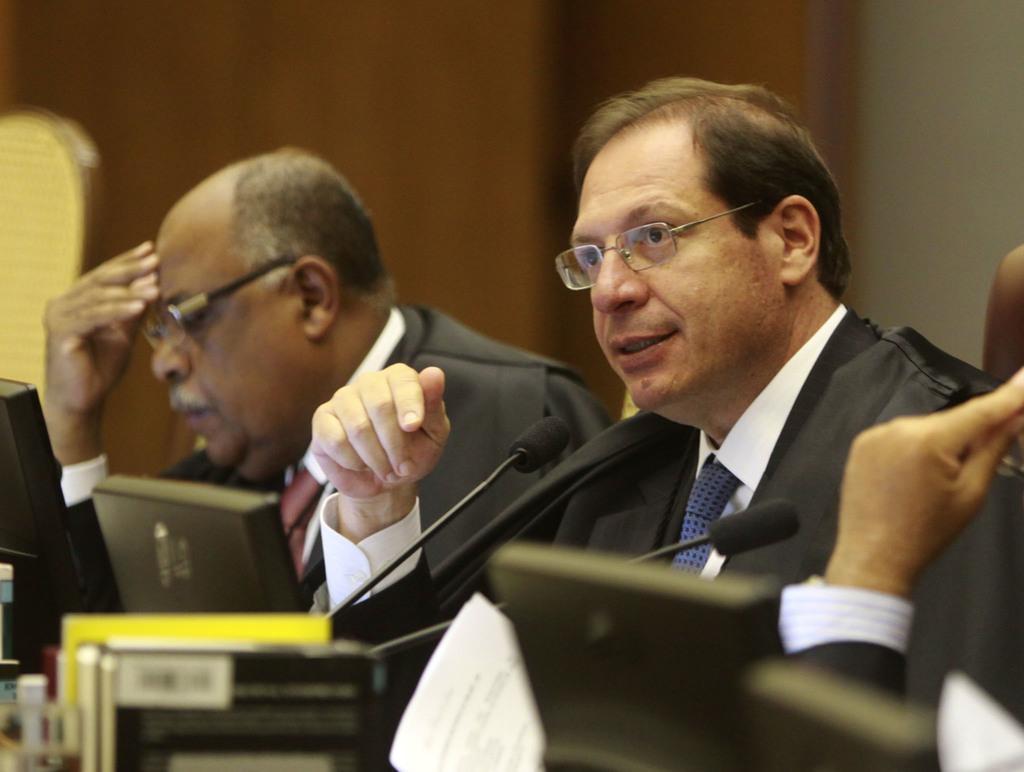In one or two sentences, can you explain what this image depicts? In this image we can see a few people, there are mice, laptops, papers and some other objects in front of them, also the background is blurred. 